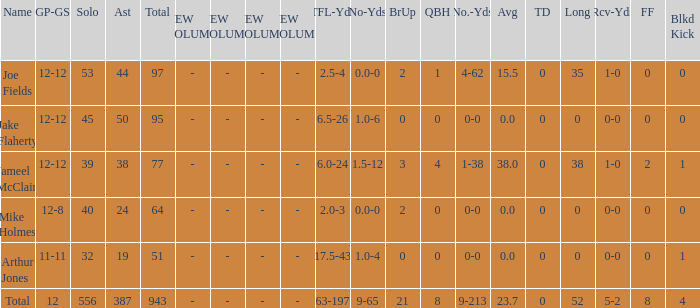What is the largest number of tds scored for a player? 0.0. Write the full table. {'header': ['Name', 'GP-GS', 'Solo', 'Ast', 'Total', 'NEW COLUMN 1', 'NEW COLUMN 2', 'NEW COLUMN 3', 'NEW COLUMN 4', 'TFL-Yds', 'No-Yds', 'BrUp', 'QBH', 'No.-Yds', 'Avg', 'TD', 'Long', 'Rcv-Yds', 'FF', 'Blkd Kick'], 'rows': [['Joe Fields', '12-12', '53', '44', '97', '-', '-', '-', '-', '2.5-4', '0.0-0', '2', '1', '4-62', '15.5', '0', '35', '1-0', '0', '0'], ['Jake Flaherty', '12-12', '45', '50', '95', '-', '-', '-', '-', '6.5-26', '1.0-6', '0', '0', '0-0', '0.0', '0', '0', '0-0', '0', '0'], ['Jameel McClain', '12-12', '39', '38', '77', '-', '-', '-', '-', '6.0-24', '1.5-12', '3', '4', '1-38', '38.0', '0', '38', '1-0', '2', '1'], ['Mike Holmes', '12-8', '40', '24', '64', '-', '-', '-', '-', '2.0-3', '0.0-0', '2', '0', '0-0', '0.0', '0', '0', '0-0', '0', '0'], ['Arthur Jones', '11-11', '32', '19', '51', '-', '-', '-', '-', '17.5-43', '1.0-4', '0', '0', '0-0', '0.0', '0', '0', '0-0', '0', '1'], ['Total', '12', '556', '387', '943', '-', '-', '-', '-', '63-197', '9-65', '21', '8', '9-213', '23.7', '0', '52', '5-2', '8', '4']]} 